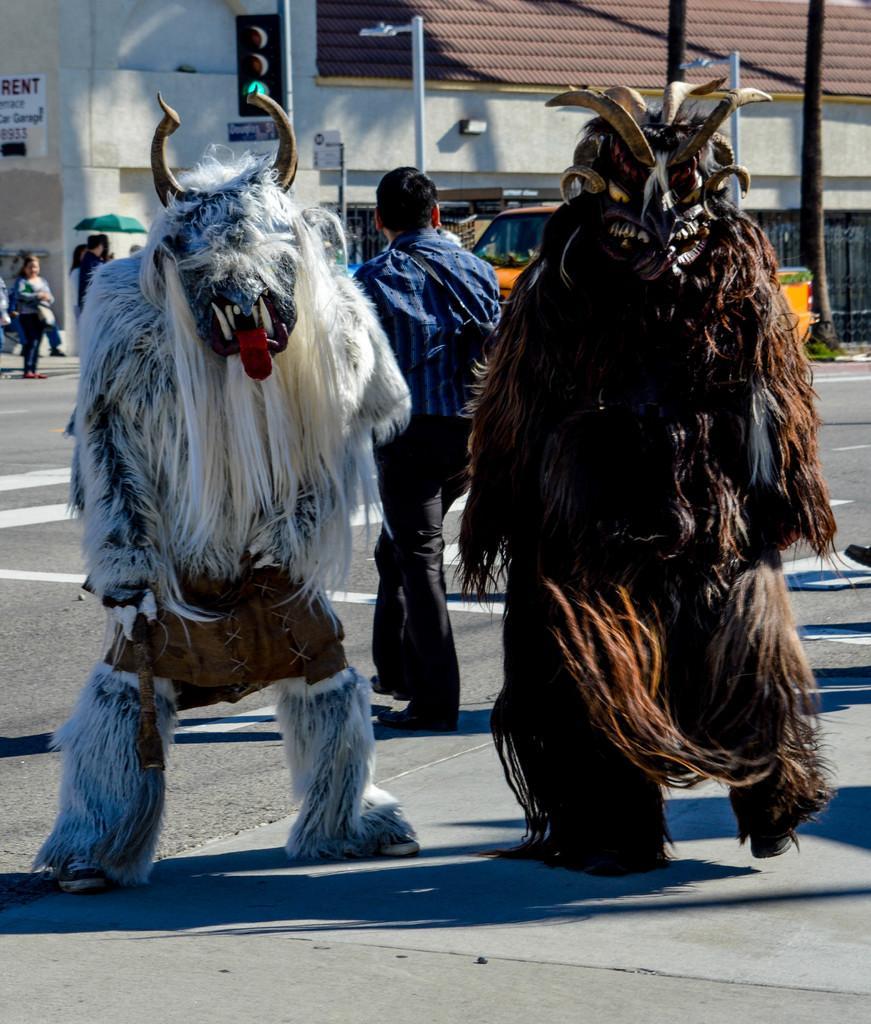Can you describe this image briefly? In the given image i can see a mask cartoons,people,electrical poles,traffic lights,house and board. 